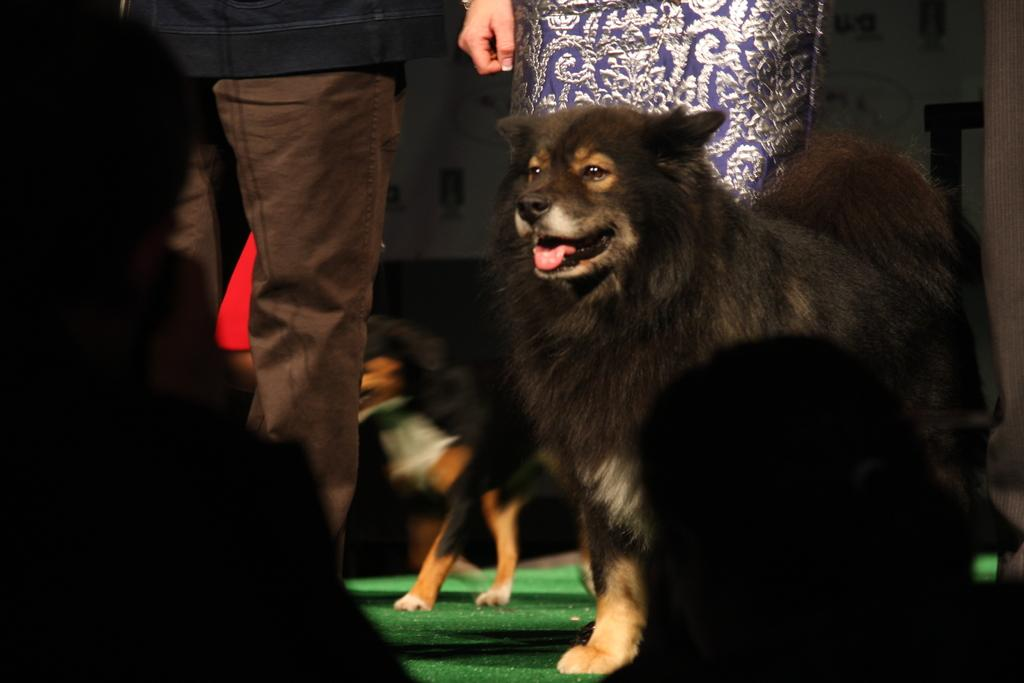What type of animals can be seen in the picture? There are dogs in the picture. Are there any humans present in the picture? Yes, there are people present in the picture. How many dimes can be seen on the ground in the picture? There are no dimes present in the picture; it features dogs and people. What type of light source is illuminating the scene in the picture? The provided facts do not mention any specific light source; the image only shows dogs and people. 